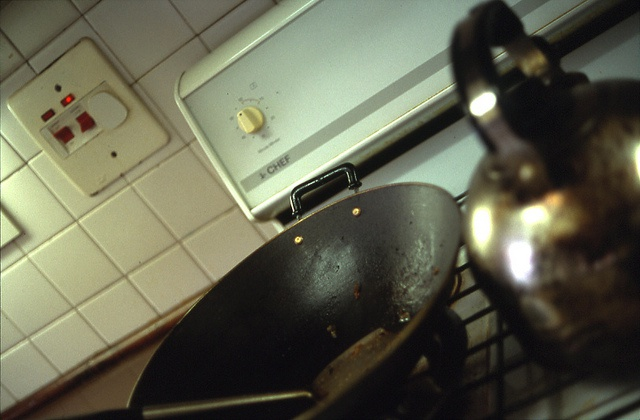Describe the objects in this image and their specific colors. I can see oven in black, darkgray, gray, and beige tones and spoon in black, darkgreen, and olive tones in this image. 